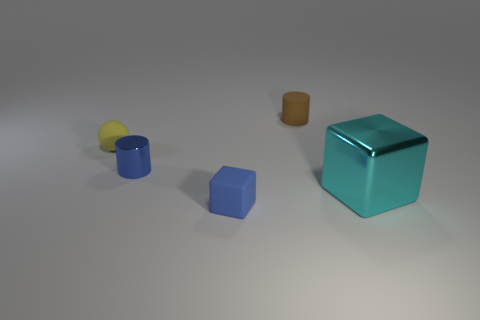Is there any other thing that is the same shape as the yellow thing?
Your response must be concise. No. The matte block has what color?
Provide a succinct answer. Blue. How many tiny objects are either red objects or spheres?
Ensure brevity in your answer.  1. Does the block to the left of the brown matte object have the same size as the shiny thing in front of the blue metal object?
Your answer should be very brief. No. There is another blue object that is the same shape as the big object; what is its size?
Offer a very short reply. Small. Is the number of cubes that are left of the cyan metal cube greater than the number of small matte cylinders on the left side of the brown object?
Provide a short and direct response. Yes. What material is the small object that is both on the right side of the metal cylinder and behind the cyan object?
Your answer should be compact. Rubber. There is another small object that is the same shape as the small blue metallic thing; what color is it?
Give a very brief answer. Brown. What is the size of the blue rubber block?
Your answer should be compact. Small. There is a rubber thing to the right of the tiny object that is in front of the cyan block; what is its color?
Offer a very short reply. Brown. 